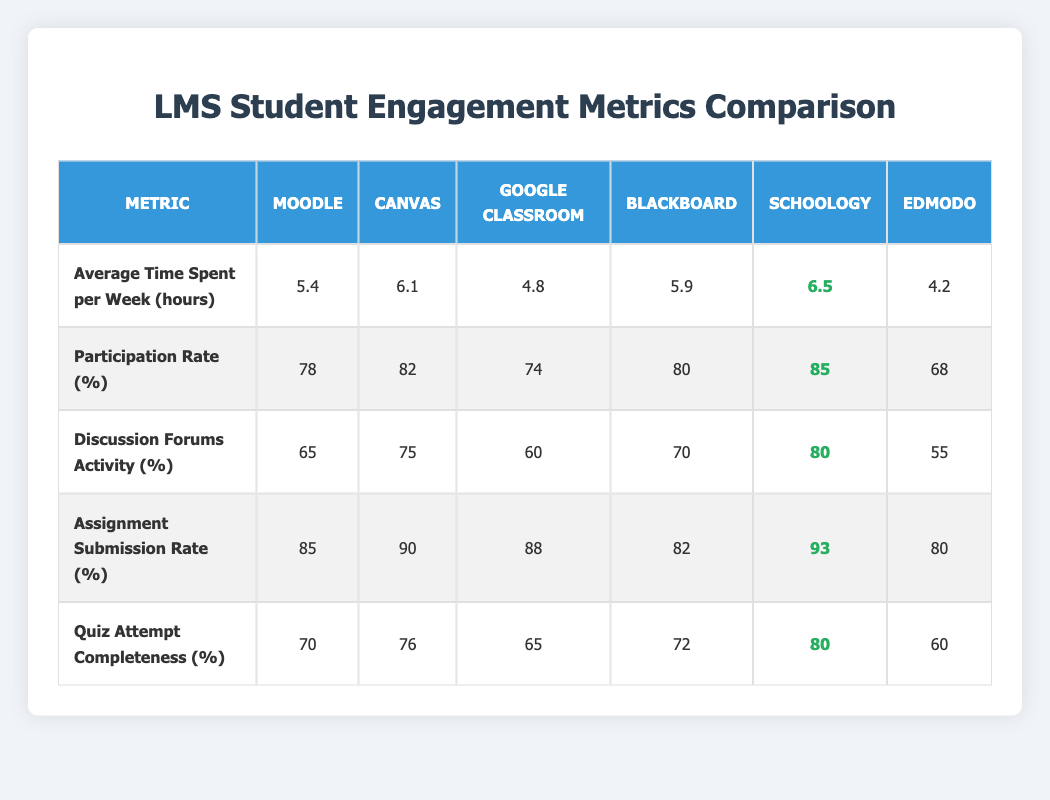What is the average time spent per week by students using Schoology? According to the table, the average time spent per week by students using Schoology is listed as 6.5 hours.
Answer: 6.5 hours Which learning management system has the highest participation rate? The participation rates for each system are listed in the table. Schoology has the highest participation rate of 85%.
Answer: Schoology What is the assignment submission rate for Google Classroom? The table shows that the assignment submission rate for Google Classroom is 88%.
Answer: 88% Is the discussion forums activity higher for Canvas or Blackboard? The table lists the discussion forums activity at 75% for Canvas and 70% for Blackboard. Thus, Canvas has a higher activity rate.
Answer: Yes, Canvas What is the difference in average time spent per week between Canvas and Edmodo? Canvas shows an average time of 6.1 hours, and Edmodo shows 4.2 hours. The difference is 6.1 - 4.2 = 1.9 hours.
Answer: 1.9 hours Which system has a higher quiz attempt completeness, Moodle or Canvas? Moodle's quiz attempt completeness is at 70%, while Canvas is at 76%. Comparing the two, Canvas has the higher value.
Answer: Canvas What is the average quiz attempt completeness across all systems? To find the average, we sum the quiz attempt completeness values: (70 + 76 + 65 + 72 + 80 + 60) = 423. There are 6 systems, so the average is 423/6 = 70.5%.
Answer: 70.5% Are there more systems with an assignment submission rate above 90% or below 80%? Checking the table, only Schoology has an assignment submission rate above 90% (93%) and the others below 80% are 78% (Moodle), 80% (Blackboard), 68% (Edmodo). Thus, the count of below 80% is greater, totaling 3 systems.
Answer: Below 80% What is the participation rate difference between the highest and lowest systems? Schoology has the highest participation rate at 85%, and Edmodo has the lowest at 68%. The difference is 85 - 68 = 17%.
Answer: 17% If you consider the average time spent per week, which system is least engaged? The lowest average time is from Edmodo at 4.2 hours per week, which indicates it has the least engagement.
Answer: Edmodo 